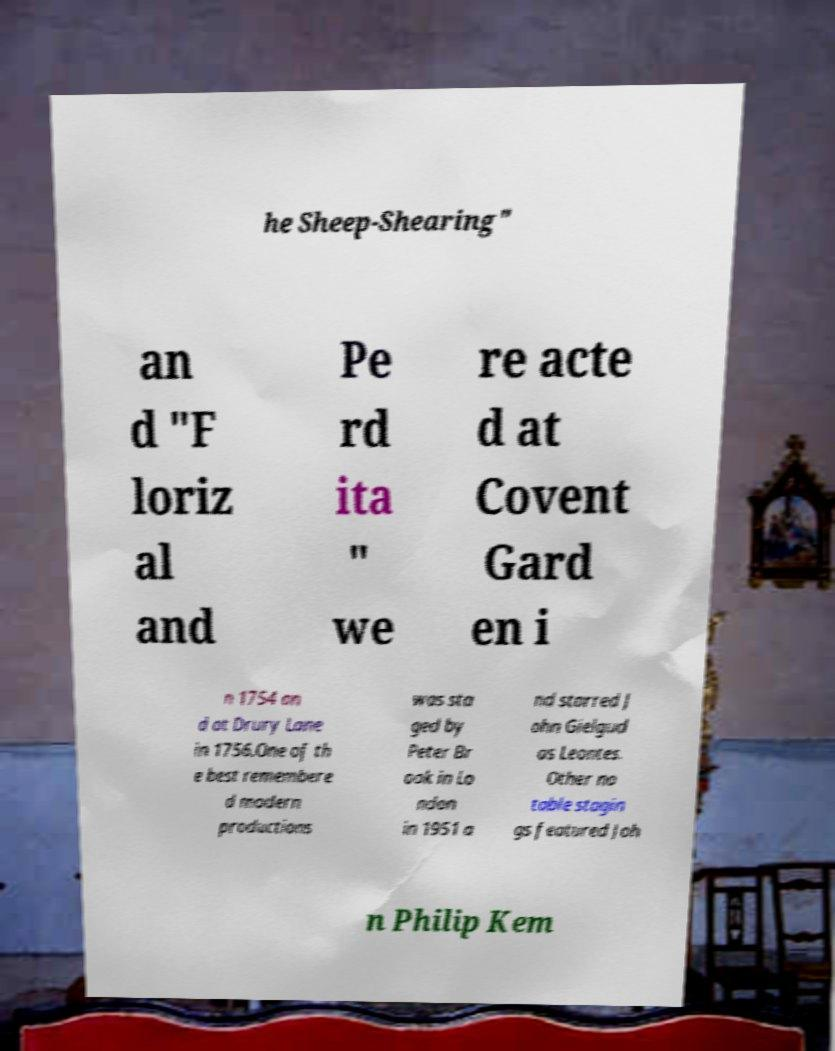Could you extract and type out the text from this image? he Sheep-Shearing" an d "F loriz al and Pe rd ita " we re acte d at Covent Gard en i n 1754 an d at Drury Lane in 1756.One of th e best remembere d modern productions was sta ged by Peter Br ook in Lo ndon in 1951 a nd starred J ohn Gielgud as Leontes. Other no table stagin gs featured Joh n Philip Kem 